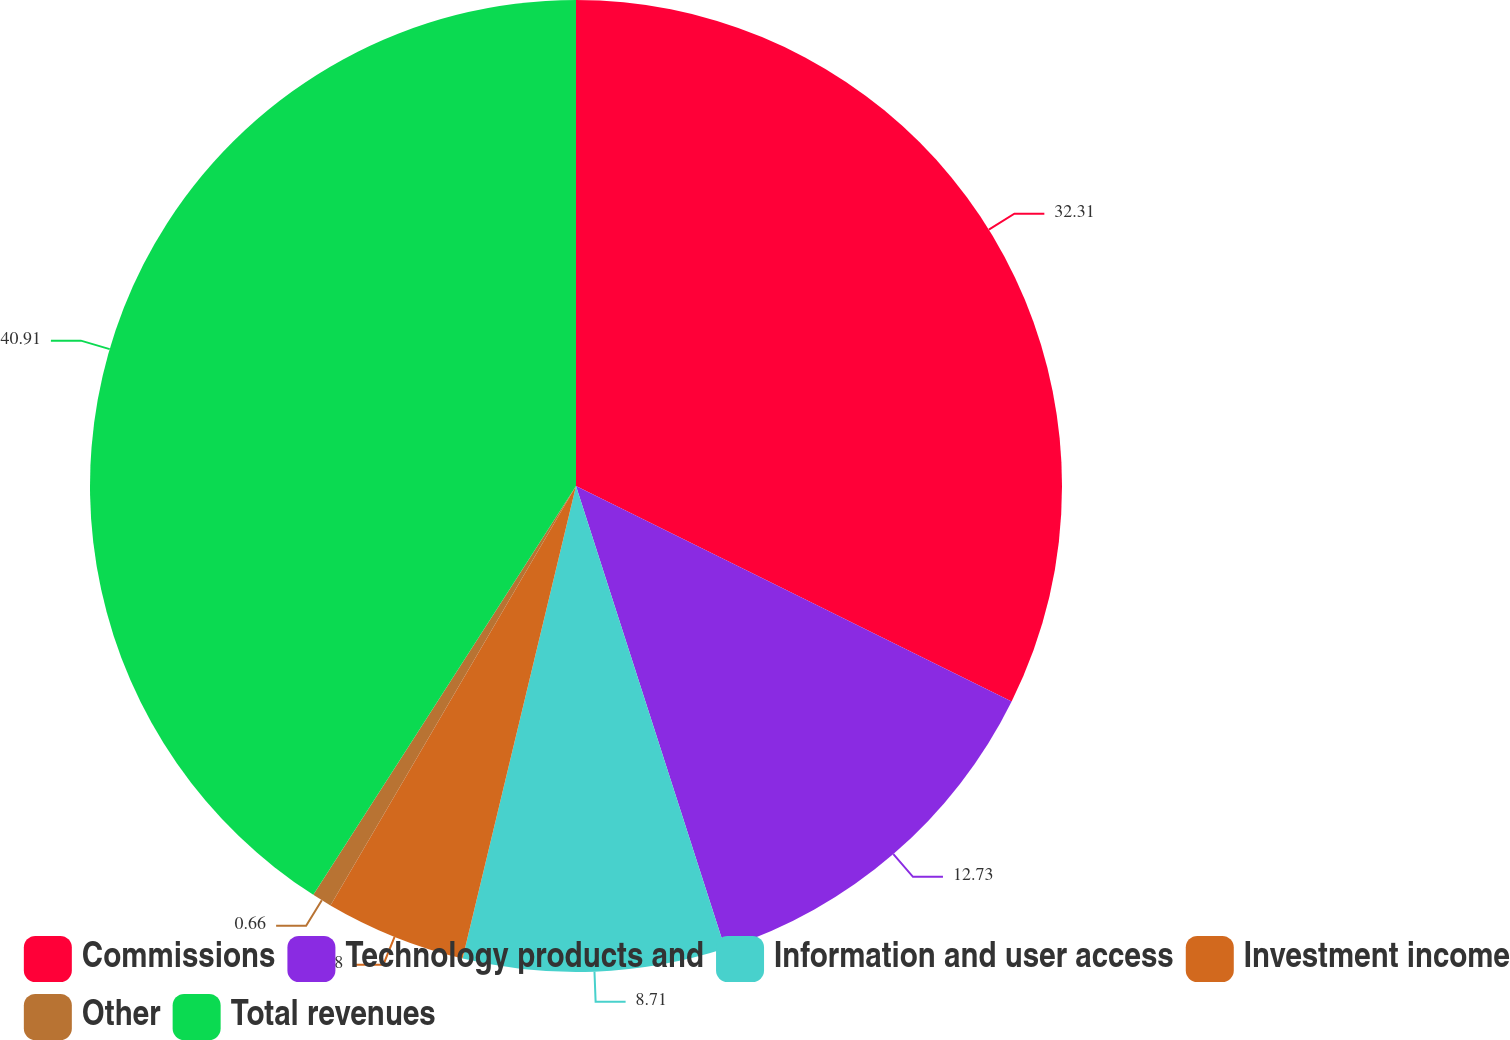Convert chart to OTSL. <chart><loc_0><loc_0><loc_500><loc_500><pie_chart><fcel>Commissions<fcel>Technology products and<fcel>Information and user access<fcel>Investment income<fcel>Other<fcel>Total revenues<nl><fcel>32.31%<fcel>12.73%<fcel>8.71%<fcel>4.68%<fcel>0.66%<fcel>40.91%<nl></chart> 